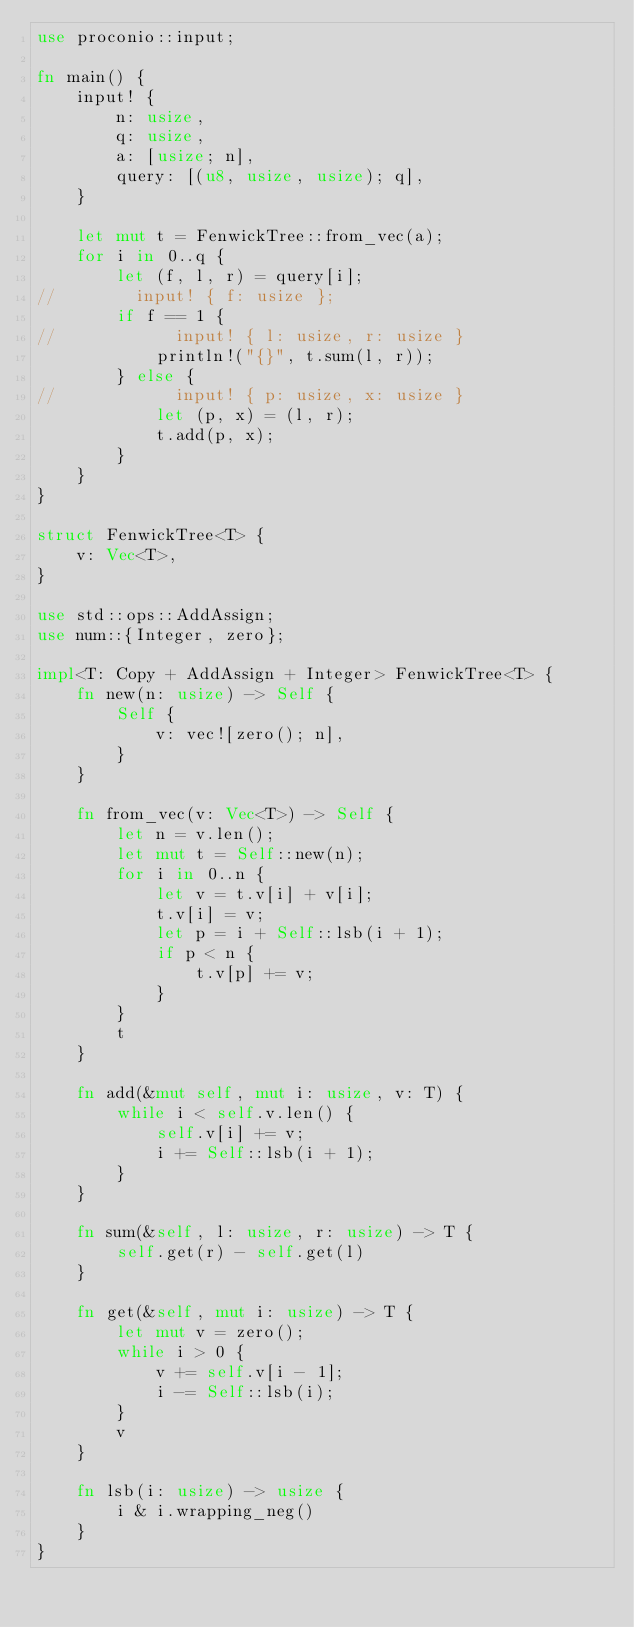<code> <loc_0><loc_0><loc_500><loc_500><_Rust_>use proconio::input;

fn main() {
    input! {
        n: usize,
        q: usize,
        a: [usize; n],
        query: [(u8, usize, usize); q],
    }

    let mut t = FenwickTree::from_vec(a);
    for i in 0..q {
        let (f, l, r) = query[i];
//        input! { f: usize };
        if f == 1 {
//            input! { l: usize, r: usize }
            println!("{}", t.sum(l, r));
        } else {
//            input! { p: usize, x: usize }
            let (p, x) = (l, r);
            t.add(p, x);
        }
    }
}

struct FenwickTree<T> {
    v: Vec<T>,
}

use std::ops::AddAssign;
use num::{Integer, zero};

impl<T: Copy + AddAssign + Integer> FenwickTree<T> {
    fn new(n: usize) -> Self {
        Self {
            v: vec![zero(); n],
        }
    }

    fn from_vec(v: Vec<T>) -> Self {
        let n = v.len();
        let mut t = Self::new(n);
        for i in 0..n {
            let v = t.v[i] + v[i];
            t.v[i] = v;
            let p = i + Self::lsb(i + 1);
            if p < n {
                t.v[p] += v;
            }
        }
        t
    }

    fn add(&mut self, mut i: usize, v: T) {
        while i < self.v.len() {
            self.v[i] += v;
            i += Self::lsb(i + 1);
        }
    }

    fn sum(&self, l: usize, r: usize) -> T {
        self.get(r) - self.get(l)
    }

    fn get(&self, mut i: usize) -> T {
        let mut v = zero();
        while i > 0 {
            v += self.v[i - 1];
            i -= Self::lsb(i);
        }
        v
    }

    fn lsb(i: usize) -> usize {
        i & i.wrapping_neg()
    }
}
</code> 